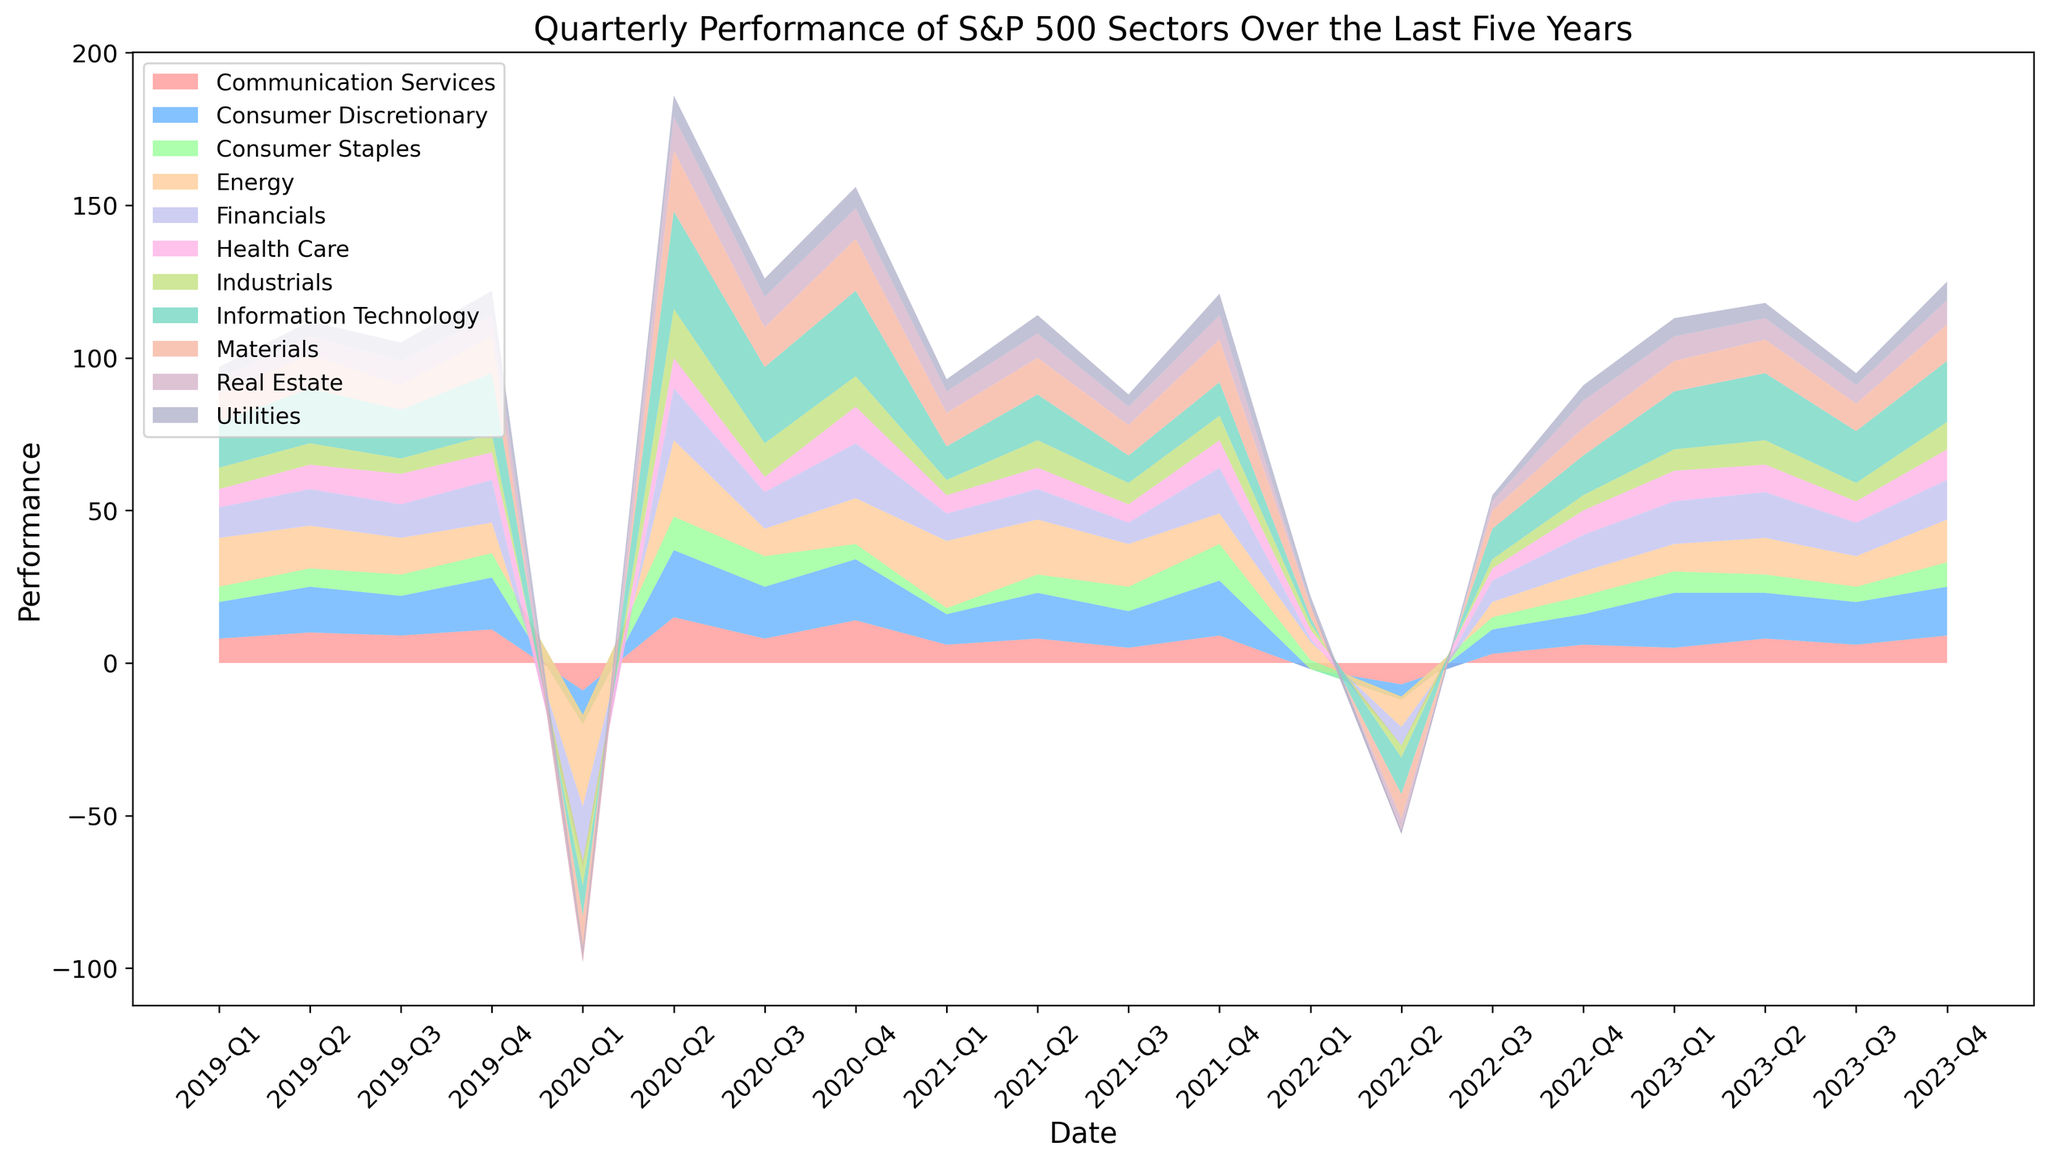Which sector had the worst performance during 2020-Q1? Observing the 2020-Q1 data, the Energy sector has the deepest dip, indicating the worst performance with a value of -30.
Answer: Energy Which sector consistently performed well in 2020-Q2 and 2020-Q4? By comparing the sectors' performance in 2020-Q2 and 2020-Q4, the Information Technology sector shows strong performance in both quarters with values of 32 in Q2 and 28 in Q4.
Answer: Information Technology What is the total performance value for the Health Care sector in 2020? Summing up the quarterly performance for Health Care in 2020: 2 (Q1) + 10 (Q2) + 5 (Q3) + 12 (Q4) = 29.
Answer: 29 Which two sectors showed the most significant drop in performance from 2020-Q4 to 2021-Q1? Comparing the performance change from 2020-Q4 to 2021-Q1, Information Technology drops from 28 to 11, and Energy drops from 15 to 9, making them the sectors with significant drops.
Answer: Information Technology and Energy Which sector showed a consistent positive performance in the first quarter of each year from 2019 to 2023? By examining the first-quarter performance values over the years, the Consumer Discretionary sector showed positive values consistently: 12 (2019), -11 (2020), 10 (2021), 0 (2022), and 18 (2023).
Answer: Consumer Discretionary From 2019 to 2023, which sector had the highest average quarterly performance? Calculating the average for each sector's quarterly performance from 2019 to 2023 and comparing them, Information Technology yields the highest average.
Answer: Information Technology How did the Utilities sector perform during the market crash in 2020-Q1 compared to 2020-Q2? Comparing Utilities in 2020-Q1 and Q2, it decreased slightly during the crash (2 in Q1) and recovered (7 in Q2).
Answer: 2020-Q1: 2, 2020-Q2: 7 Which sector's performance recovered the fastest after the 2020-Q1 market crash? Observing the performance change from 2020-Q1 to Q2, Information Technology rebounds significantly from -10 to 32, indicating the fastest recovery.
Answer: Information Technology What is the difference in performance between the Financials and Real Estate sectors in 2021-Q4? Finding the difference, Financials at 15 minus Real Estate at 8, gives 7.
Answer: 7 